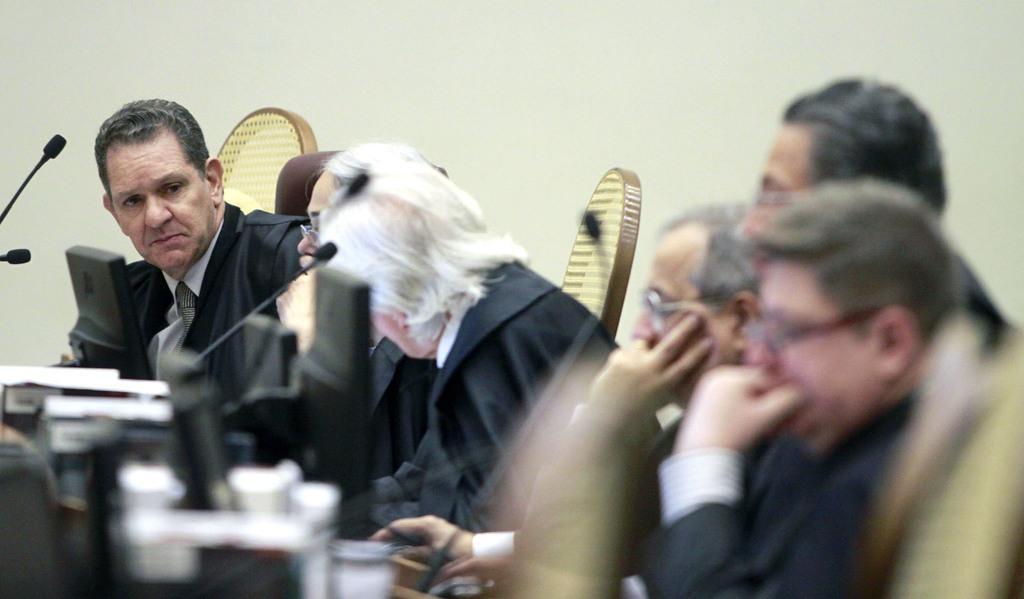Describe this image in one or two sentences. There are people sitting on the chairs in the foreground area of the image, there are mics and monitors in front of them. 